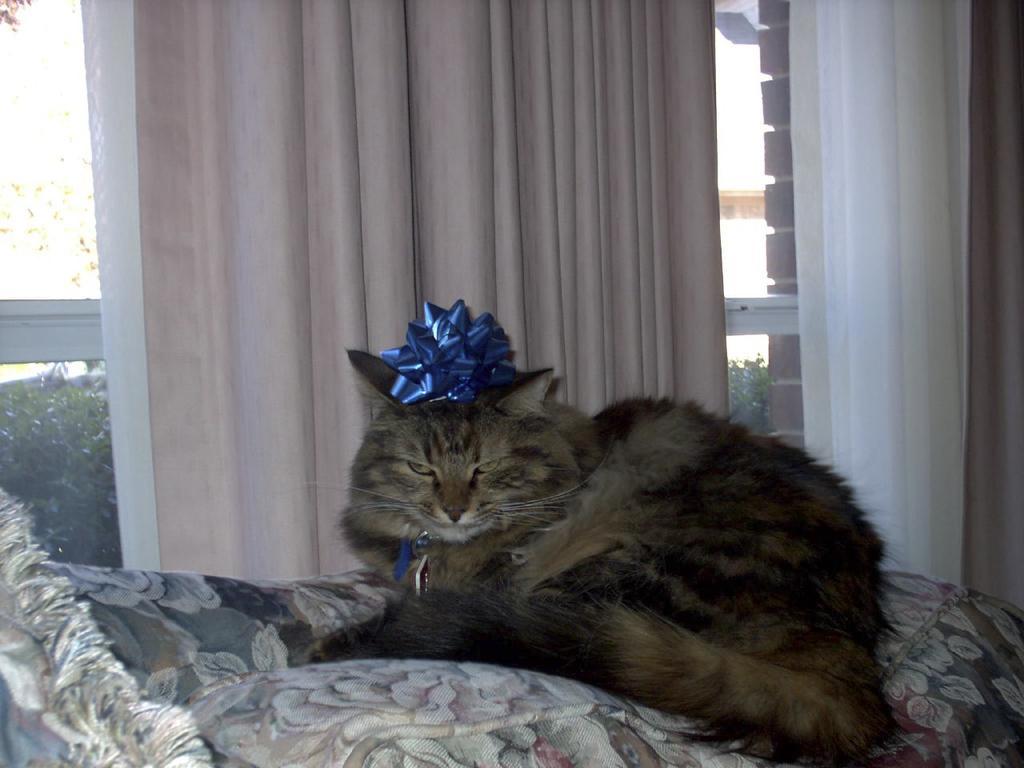Please provide a concise description of this image. In the background we can see a window and curtains. Through the glass outside view is visible. We can see plants. In this picture we can see a cat sitting on the couch. We can see blue object placed on the top of a cat. 